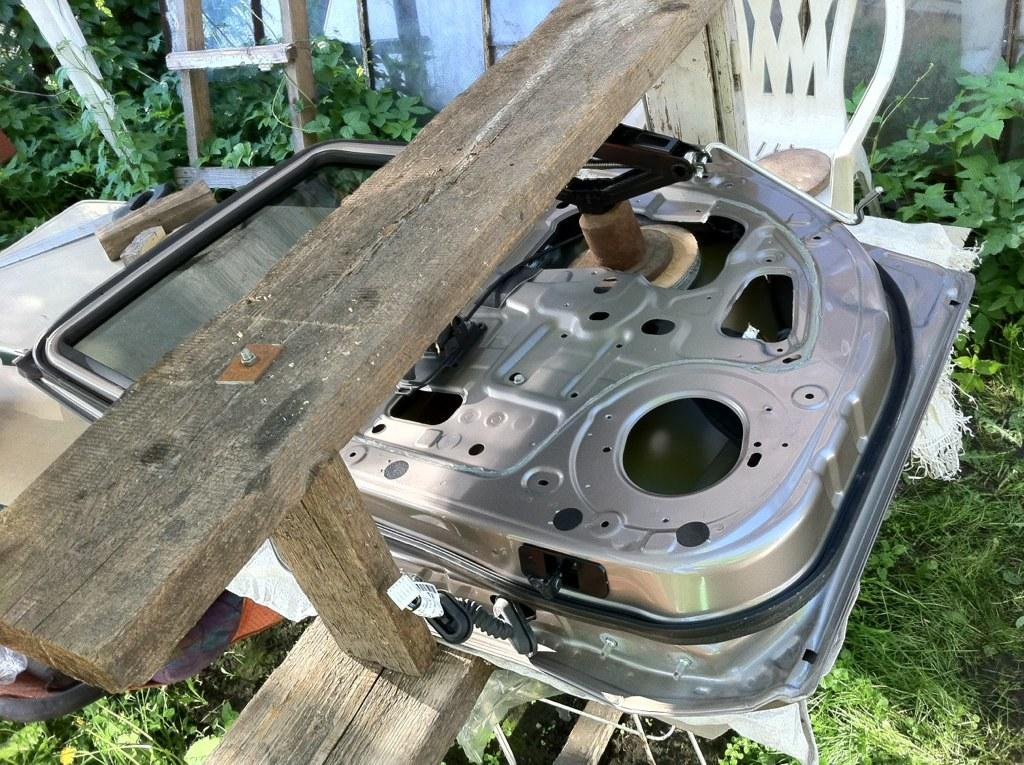What is placed on the wooden bench in the image? There is an object placed on a wooden bench in the image, but the specific object is not mentioned in the facts. What other furniture can be seen in the image? There is a chair in the background of the image. What is located near the chair in the background? There is a ladder in the background of the image. What type of natural environment is visible in the image? Grass is visible in the image, suggesting a grassy area or lawn. What type of vegetation is present in the image? There are plants in the image. Can you tell me how many doors are visible in the image? There is no door present in the image; only a wooden bench, a chair, a ladder, grass, and plants are visible. What type of glove is being used by the person in the image? There is no person or glove present in the image. 